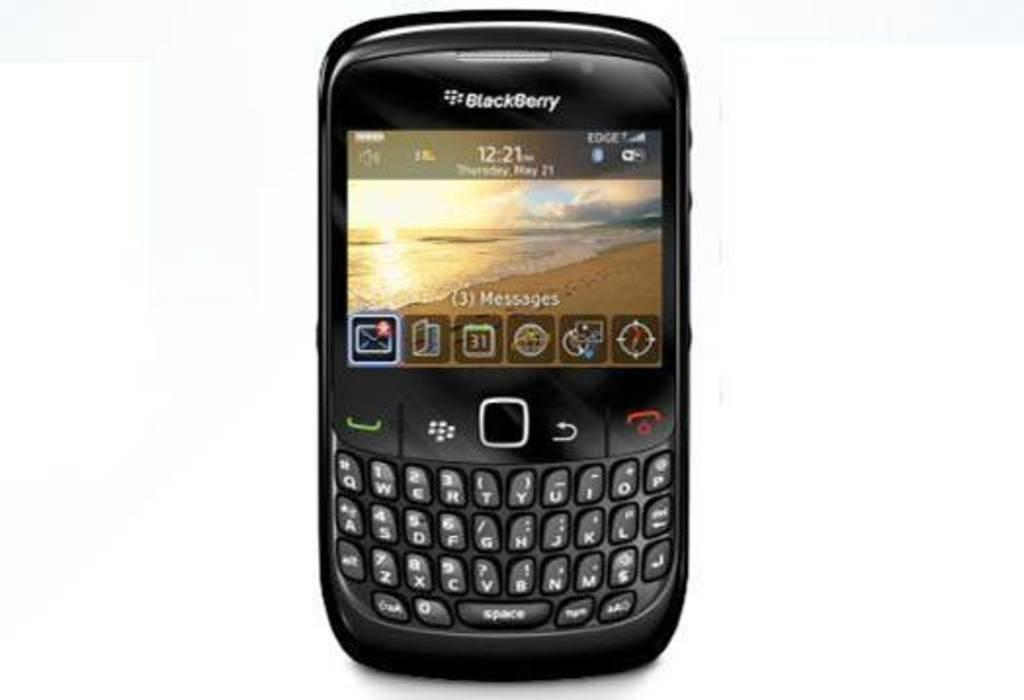<image>
Describe the image concisely. A blackberry device showing the current time as 12:21 